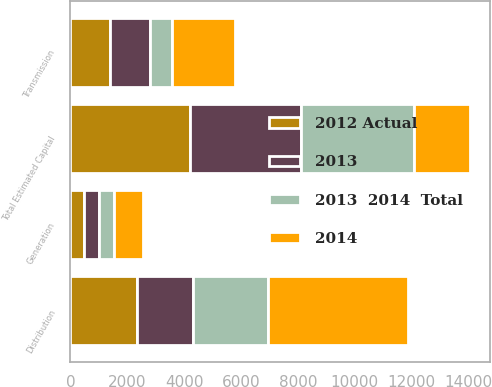Convert chart to OTSL. <chart><loc_0><loc_0><loc_500><loc_500><stacked_bar_chart><ecel><fcel>Transmission<fcel>Distribution<fcel>Generation<fcel>Total Estimated Capital<nl><fcel>2013<fcel>1390<fcel>1995<fcel>526<fcel>3911<nl><fcel>2012 Actual<fcel>1396<fcel>2329<fcel>485<fcel>4210<nl><fcel>2013  2014  Total<fcel>802<fcel>2617<fcel>532<fcel>3951<nl><fcel>2014<fcel>2198<fcel>4946<fcel>1017<fcel>1995<nl></chart> 